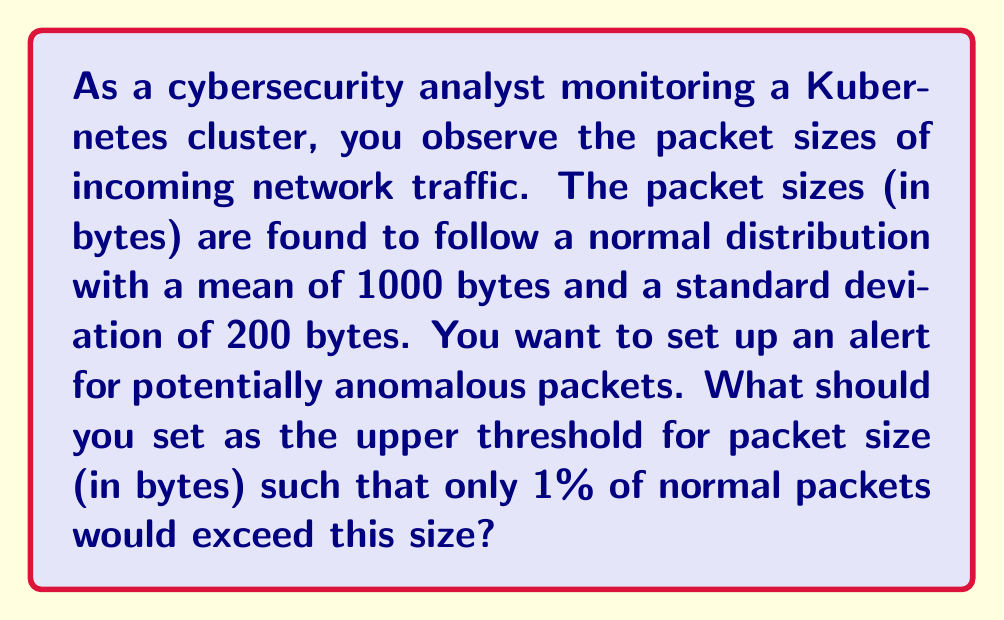Solve this math problem. To solve this problem, we need to use the properties of the normal distribution and the concept of z-scores.

1. We're given:
   - Mean ($\mu$) = 1000 bytes
   - Standard deviation ($\sigma$) = 200 bytes
   - We want the value that is exceeded by only 1% of packets

2. In a normal distribution, the area to the right of the z-score of 2.326 is 0.01 (1%).

3. The z-score formula is:
   $$z = \frac{x - \mu}{\sigma}$$
   where $x$ is the value we're looking for.

4. We can rearrange this to solve for $x$:
   $$x = \mu + z\sigma$$

5. Plugging in our values:
   $$x = 1000 + (2.326 * 200)$$

6. Calculate:
   $$x = 1000 + 465.2 = 1465.2$$

7. Round up to the nearest byte:
   $$x = 1466 \text{ bytes}$$

This means that 99% of normal packets will be smaller than 1466 bytes, and only 1% will exceed this size.
Answer: 1466 bytes 